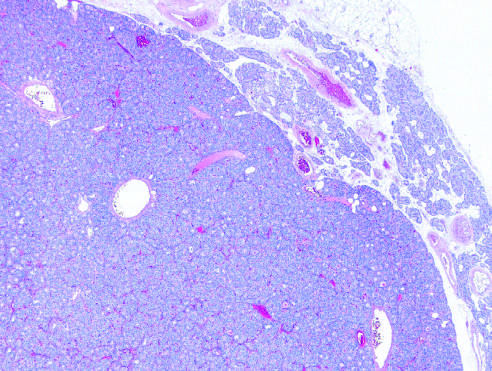s the epithelium above the intact basement membrane delineated from the residual normocellular gland on the upper right in this low-power view?
Answer the question using a single word or phrase. No 